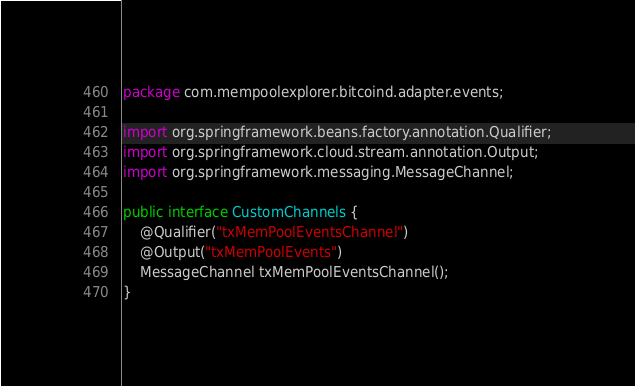<code> <loc_0><loc_0><loc_500><loc_500><_Java_>package com.mempoolexplorer.bitcoind.adapter.events;

import org.springframework.beans.factory.annotation.Qualifier;
import org.springframework.cloud.stream.annotation.Output;
import org.springframework.messaging.MessageChannel;

public interface CustomChannels {
	@Qualifier("txMemPoolEventsChannel")
	@Output("txMemPoolEvents")
    MessageChannel txMemPoolEventsChannel();
}</code> 